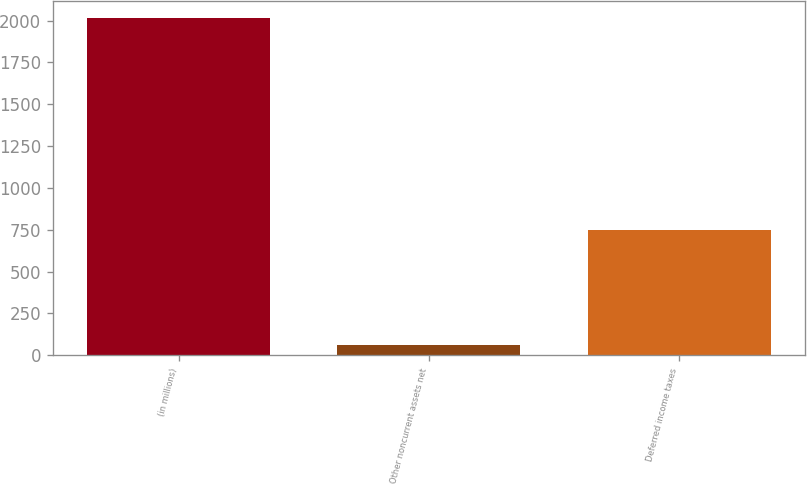Convert chart. <chart><loc_0><loc_0><loc_500><loc_500><bar_chart><fcel>(in millions)<fcel>Other noncurrent assets net<fcel>Deferred income taxes<nl><fcel>2016<fcel>61.7<fcel>751.7<nl></chart> 